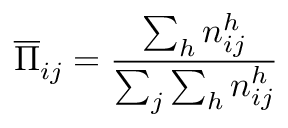Convert formula to latex. <formula><loc_0><loc_0><loc_500><loc_500>\overline { \Pi } _ { i j } = \frac { \sum _ { h } n _ { i j } ^ { h } } { \sum _ { j } \sum _ { h } n _ { i j } ^ { h } }</formula> 